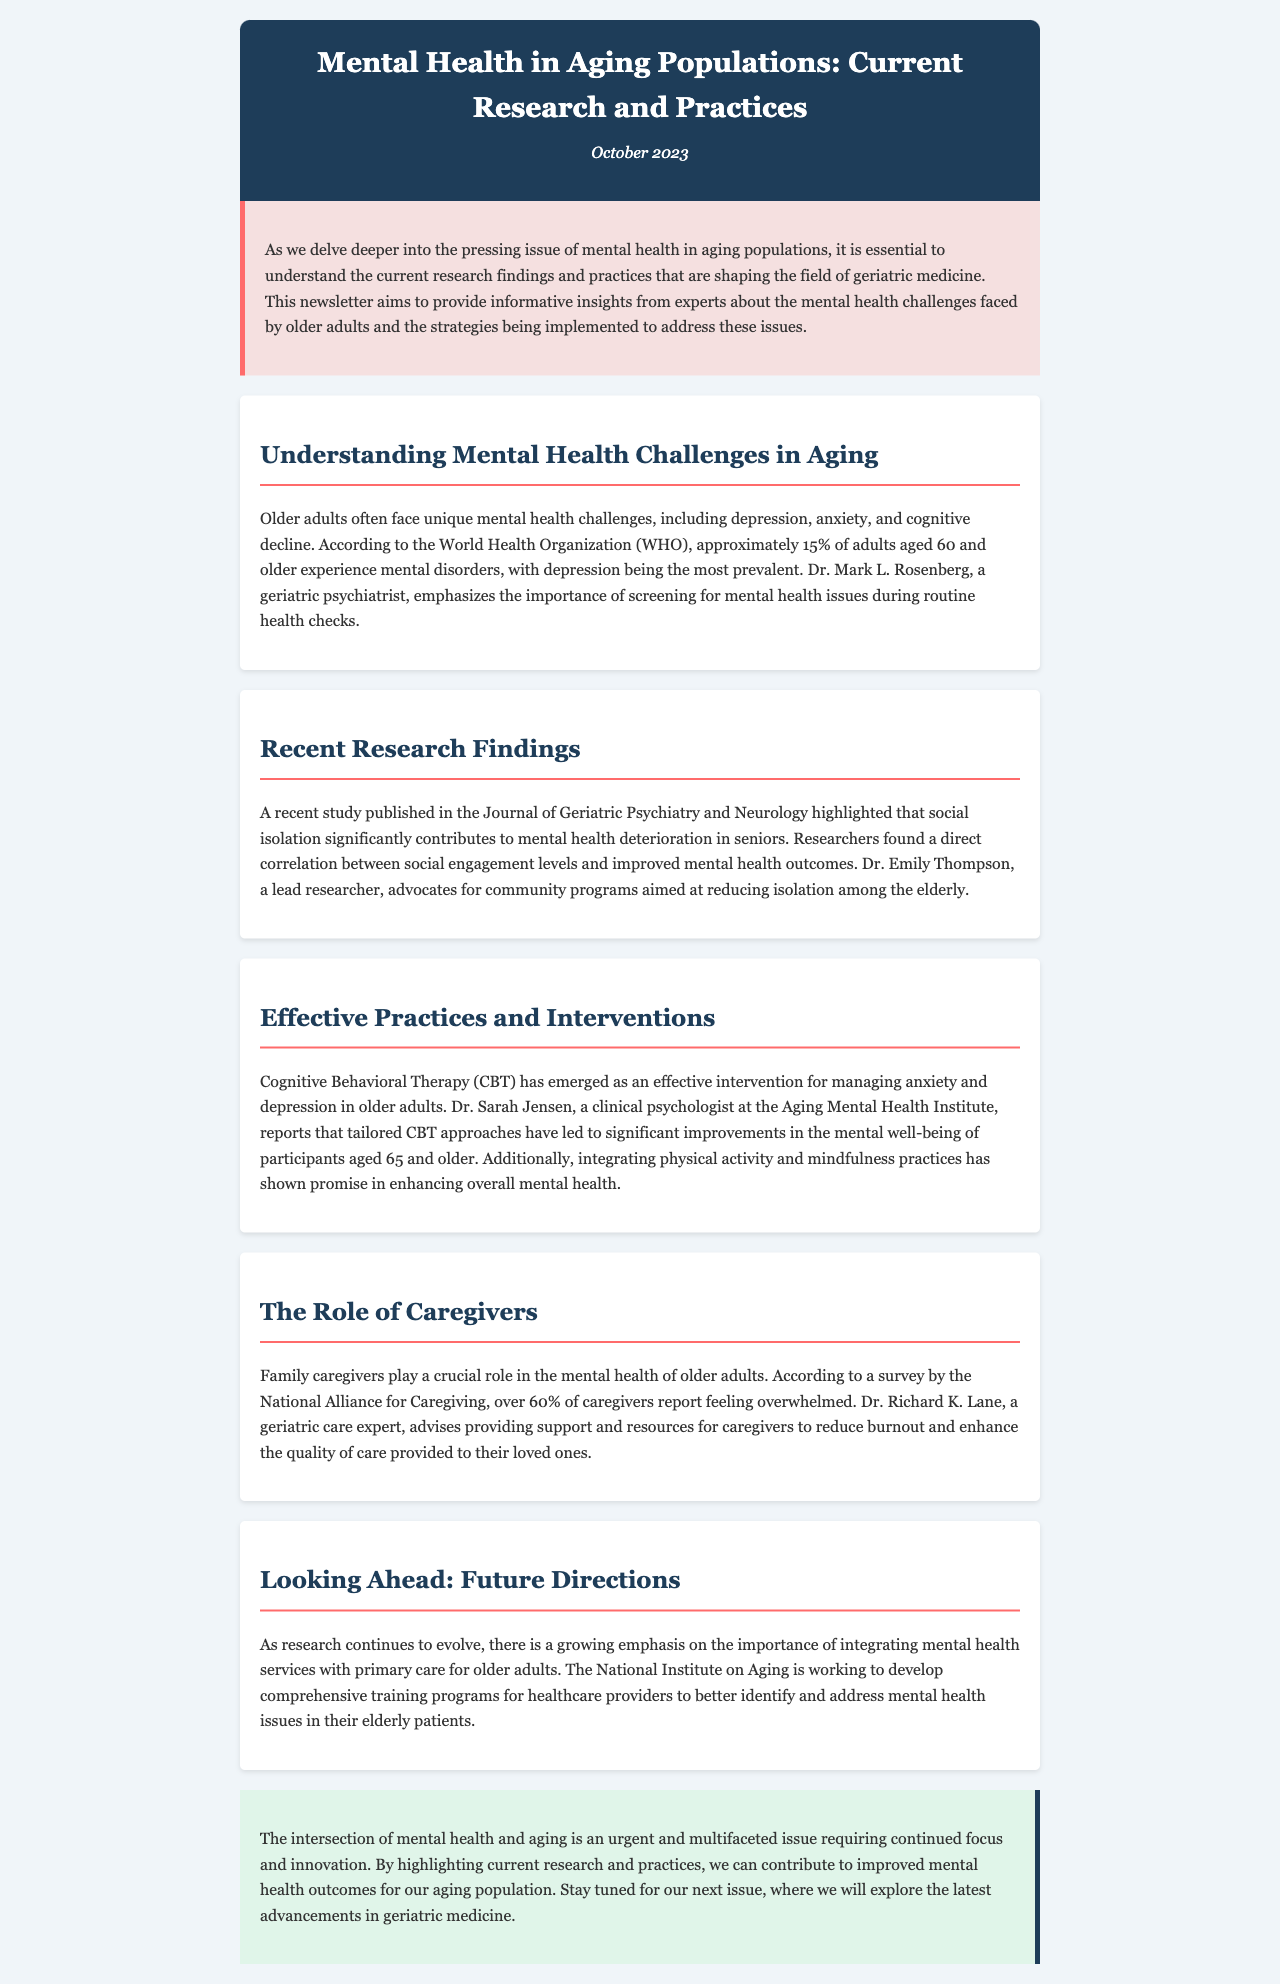What percentage of adults aged 60 and older experience mental disorders? The document states that approximately 15% of adults aged 60 and older experience mental disorders.
Answer: 15% Who emphasizes the importance of screening for mental health issues during routine health checks? Dr. Mark L. Rosenberg, a geriatric psychiatrist, emphasizes this importance.
Answer: Dr. Mark L. Rosenberg What correlation was found in a recent study regarding social engagement levels? The study highlighted a direct correlation between social engagement levels and improved mental health outcomes in seniors.
Answer: Direct correlation Which therapy has emerged as effective for managing anxiety and depression in older adults? Cognitive Behavioral Therapy (CBT) has emerged as an effective intervention.
Answer: Cognitive Behavioral Therapy (CBT) What percentage of caregivers report feeling overwhelmed, according to a survey? According to the survey, over 60% of caregivers report feeling overwhelmed.
Answer: Over 60% What is the role of the National Institute on Aging regarding mental health services? The National Institute on Aging is working to develop comprehensive training programs for healthcare providers.
Answer: Comprehensive training programs What is the focus of the conclusion section of the newsletter? The conclusion emphasizes the urgent and multifaceted issue of mental health and aging, requiring continued focus and innovation.
Answer: Urgent and multifaceted issue What is identified as a promising addition to enhancing overall mental health? Integrating physical activity and mindfulness practices is identified as promising.
Answer: Physical activity and mindfulness practices 